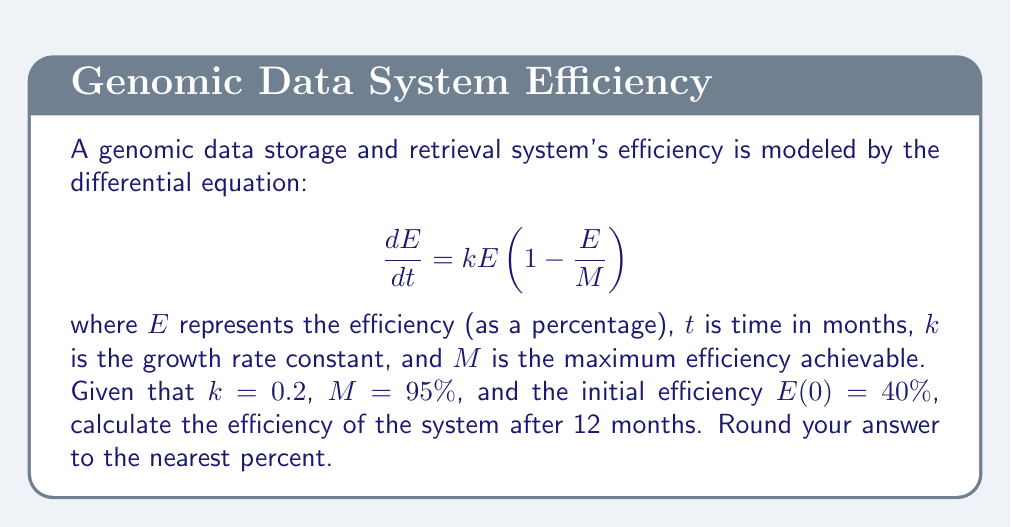Show me your answer to this math problem. To solve this problem, we need to use the logistic growth model, which is a first-order differential equation. Let's approach this step-by-step:

1) The general solution for the logistic growth model is:

   $$E(t) = \frac{M}{1 + (\frac{M}{E_0} - 1)e^{-kt}}$$

   where $E_0$ is the initial efficiency.

2) We are given:
   - $k = 0.2$
   - $M = 95\%$
   - $E_0 = 40\%$
   - $t = 12$ months

3) Let's substitute these values into the equation:

   $$E(12) = \frac{95}{1 + (\frac{95}{40} - 1)e^{-0.2(12)}}$$

4) Simplify the fraction inside the parentheses:

   $$E(12) = \frac{95}{1 + (2.375 - 1)e^{-2.4}}$$

5) Evaluate $e^{-2.4}$:

   $$E(12) = \frac{95}{1 + 1.375 \cdot 0.0907}$$

6) Multiply in the denominator:

   $$E(12) = \frac{95}{1 + 0.1247}$$

7) Add in the denominator:

   $$E(12) = \frac{95}{1.1247}$$

8) Divide:

   $$E(12) = 84.47\%$$

9) Rounding to the nearest percent:

   $$E(12) \approx 84\%$$
Answer: 84% 